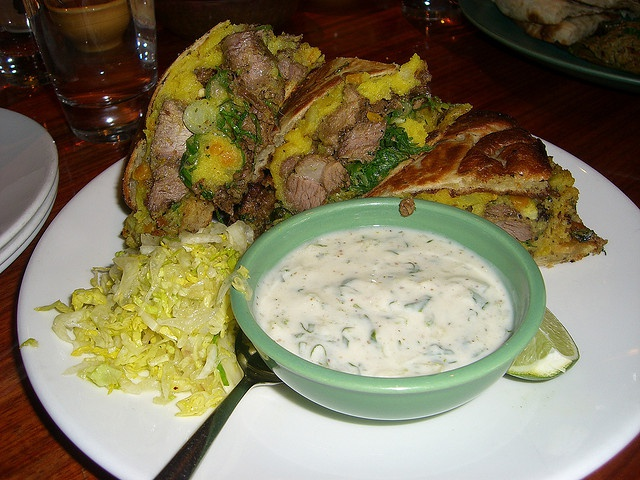Describe the objects in this image and their specific colors. I can see bowl in black, beige, green, and darkgray tones, dining table in black, maroon, darkgray, and olive tones, sandwich in black, olive, and maroon tones, sandwich in black, olive, and maroon tones, and cup in black, maroon, and gray tones in this image. 